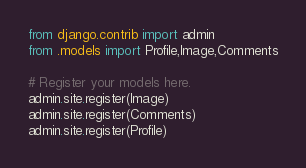<code> <loc_0><loc_0><loc_500><loc_500><_Python_>from django.contrib import admin
from .models import Profile,Image,Comments

# Register your models here.
admin.site.register(Image)
admin.site.register(Comments)
admin.site.register(Profile)</code> 